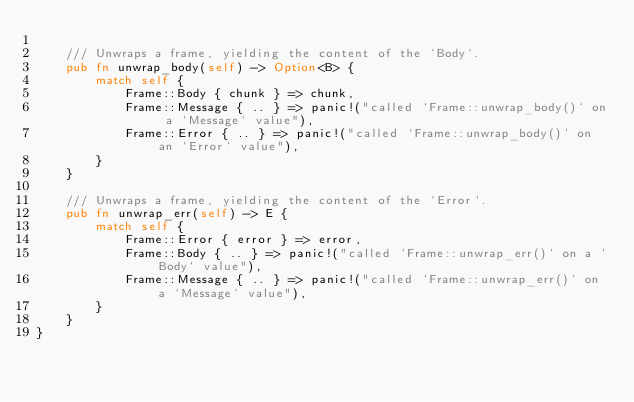Convert code to text. <code><loc_0><loc_0><loc_500><loc_500><_Rust_>
    /// Unwraps a frame, yielding the content of the `Body`.
    pub fn unwrap_body(self) -> Option<B> {
        match self {
            Frame::Body { chunk } => chunk,
            Frame::Message { .. } => panic!("called `Frame::unwrap_body()` on a `Message` value"),
            Frame::Error { .. } => panic!("called `Frame::unwrap_body()` on an `Error` value"),
        }
    }

    /// Unwraps a frame, yielding the content of the `Error`.
    pub fn unwrap_err(self) -> E {
        match self {
            Frame::Error { error } => error,
            Frame::Body { .. } => panic!("called `Frame::unwrap_err()` on a `Body` value"),
            Frame::Message { .. } => panic!("called `Frame::unwrap_err()` on a `Message` value"),
        }
    }
}
</code> 